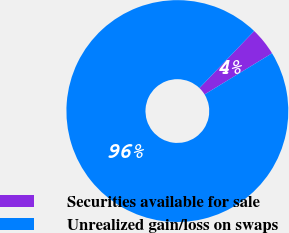Convert chart. <chart><loc_0><loc_0><loc_500><loc_500><pie_chart><fcel>Securities available for sale<fcel>Unrealized gain/loss on swaps<nl><fcel>4.11%<fcel>95.89%<nl></chart> 